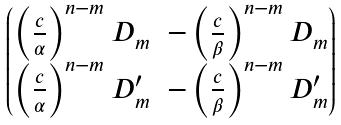Convert formula to latex. <formula><loc_0><loc_0><loc_500><loc_500>\begin{pmatrix} \left ( \frac { c } { \alpha } \right ) ^ { n - m } D _ { m } & - \left ( \frac { c } { \beta } \right ) ^ { n - m } D _ { m } \\ \left ( \frac { c } { \alpha } \right ) ^ { n - m } D _ { m } ^ { \prime } & - \left ( \frac { c } { \beta } \right ) ^ { n - m } D _ { m } ^ { \prime } \end{pmatrix}</formula> 